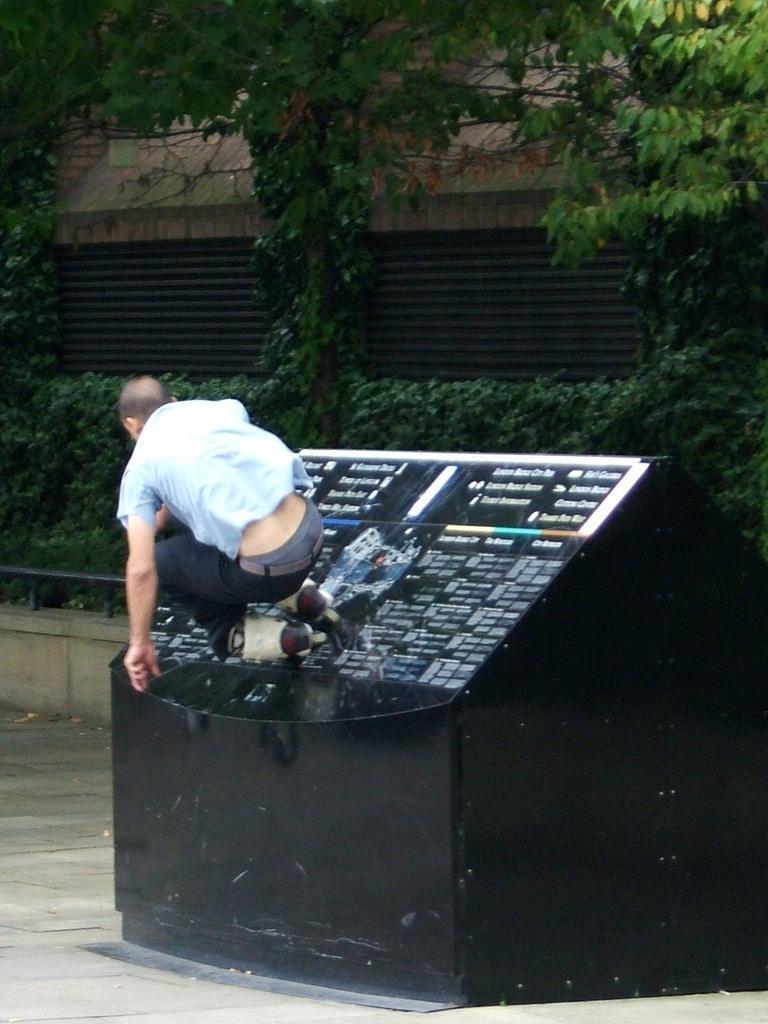How would you summarize this image in a sentence or two? In this picture we can see a man who is jumping. This is an electronic device. These are the plants. And this is tree. 